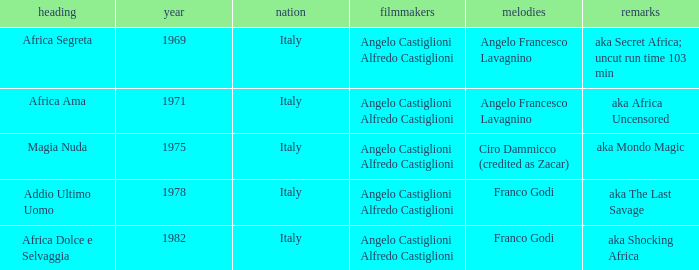Which music has the notes of AKA Africa Uncensored? Angelo Francesco Lavagnino. 